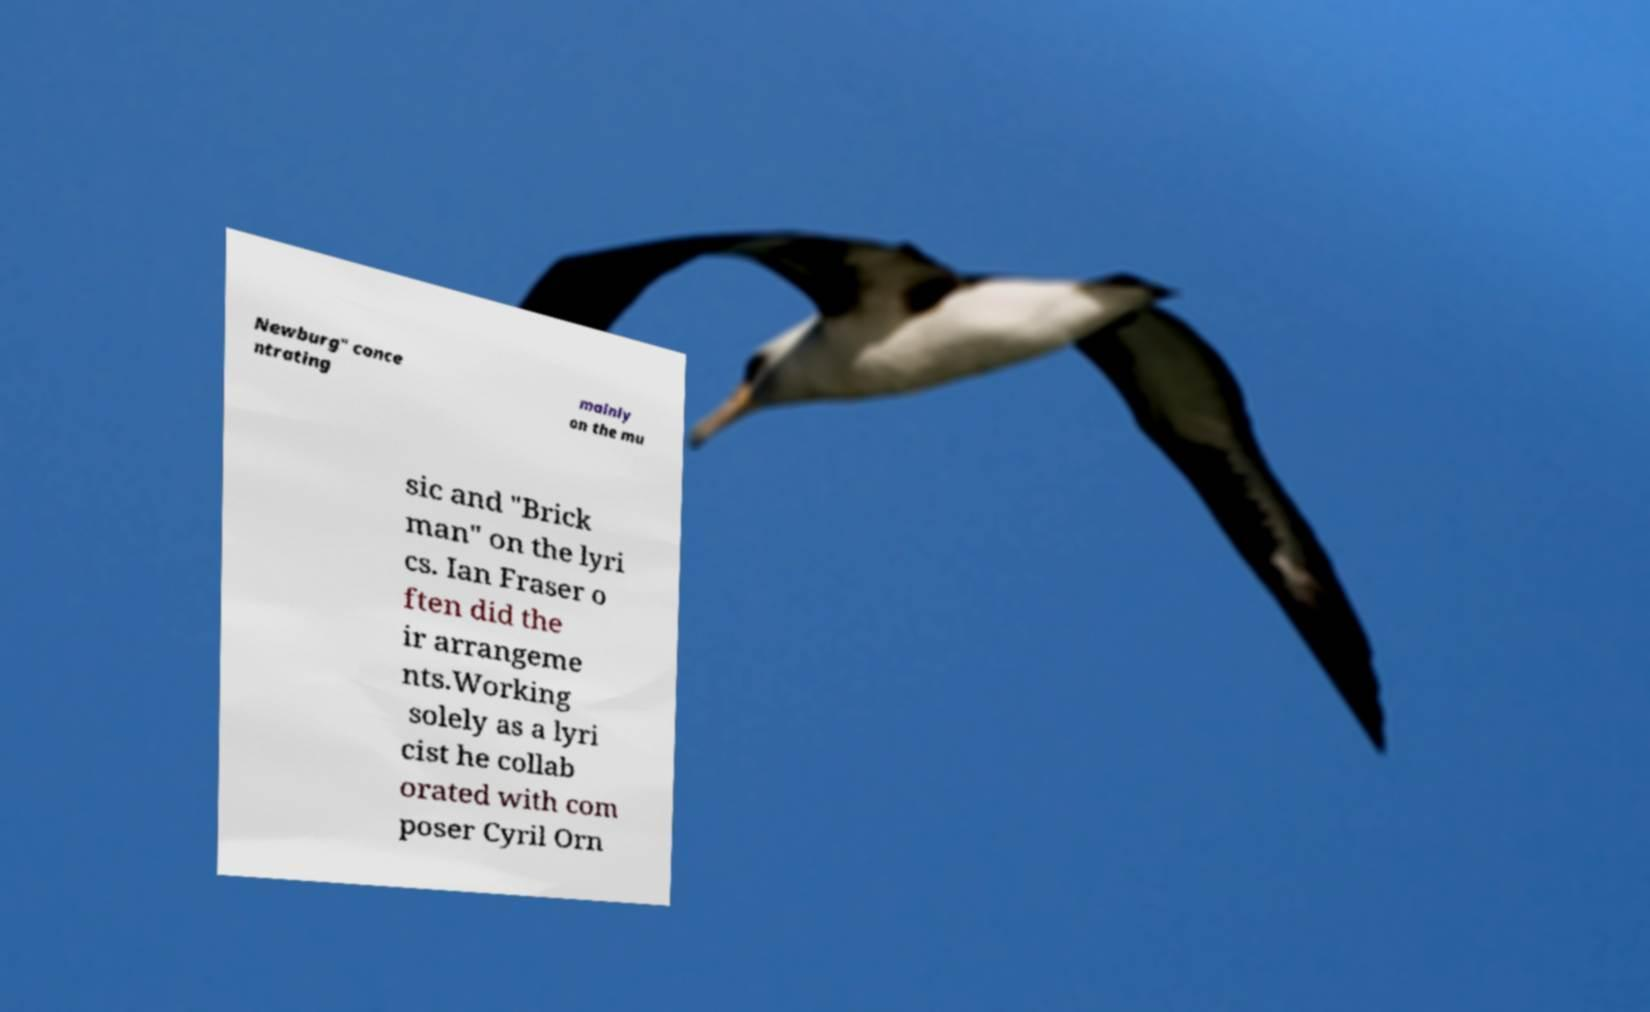For documentation purposes, I need the text within this image transcribed. Could you provide that? Newburg" conce ntrating mainly on the mu sic and "Brick man" on the lyri cs. Ian Fraser o ften did the ir arrangeme nts.Working solely as a lyri cist he collab orated with com poser Cyril Orn 